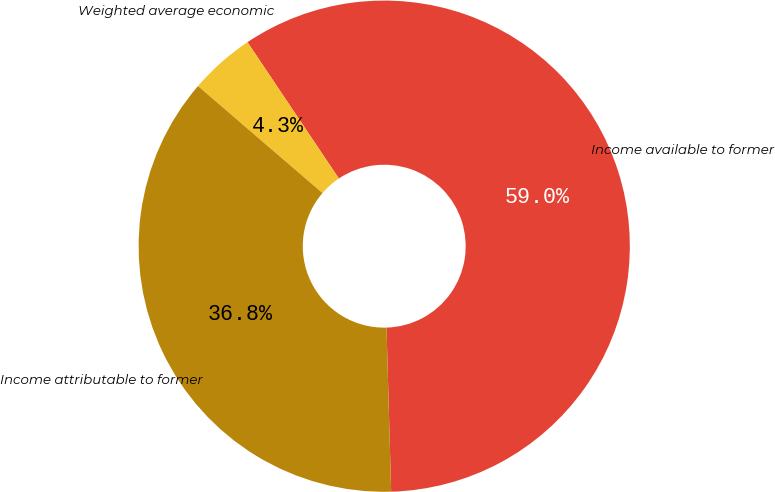Convert chart. <chart><loc_0><loc_0><loc_500><loc_500><pie_chart><fcel>Income available to former<fcel>Weighted average economic<fcel>Income attributable to former<nl><fcel>58.95%<fcel>4.3%<fcel>36.75%<nl></chart> 